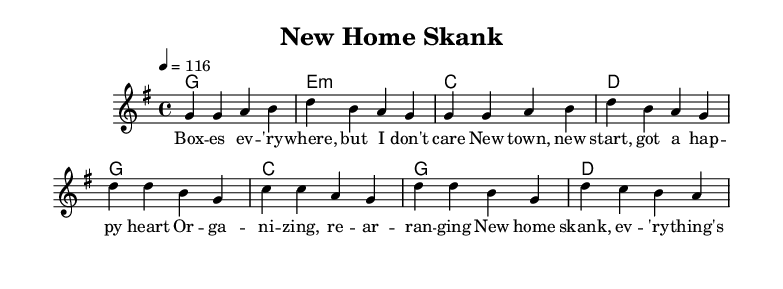What is the key signature of this music? The key signature is G major, which has one sharp note (F#). This can be identified by looking at the key signature at the beginning of the staff.
Answer: G major What is the time signature of this music? The time signature is 4/4, indicated by the fraction shown at the beginning of the piece where it also indicates the rhythmic structure as four beats in each measure.
Answer: 4/4 What is the tempo marking for this piece? The tempo marking is 116 beats per minute (bpm), specified by the tempo indication at the beginning of the score. It indicates the speed at which the piece should be played.
Answer: 116 How many measures are in the verse? The verse has a total of 4 measures, which can be counted from the notation provided that showcases a repeated section with bar lines.
Answer: 4 What mood does the chorus lyrics convey? The chorus lyrics express a positive, upbeat mood, focusing on feelings of organization and change as indicated by the words "organizing, rearranging" along with the use of the word "happy" in the verse. This reflects the overall joyful and lively nature characteristic of reggae music.
Answer: Positive Which chord follows the 'd' chord in the chorus? The chord that follows the 'd' chord in the chorus is the 'c' chord, as specified in the chord progression stated above the melody.
Answer: c 